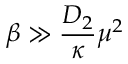<formula> <loc_0><loc_0><loc_500><loc_500>\beta \gg \frac { D _ { 2 } } { \kappa } \mu ^ { 2 }</formula> 